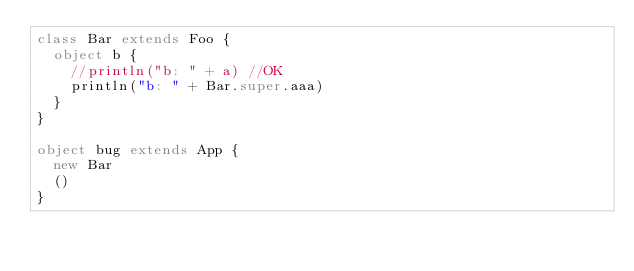Convert code to text. <code><loc_0><loc_0><loc_500><loc_500><_Scala_>class Bar extends Foo {
  object b {
    //println("b: " + a) //OK
    println("b: " + Bar.super.aaa)
  }
}

object bug extends App {
  new Bar
  ()
}
</code> 